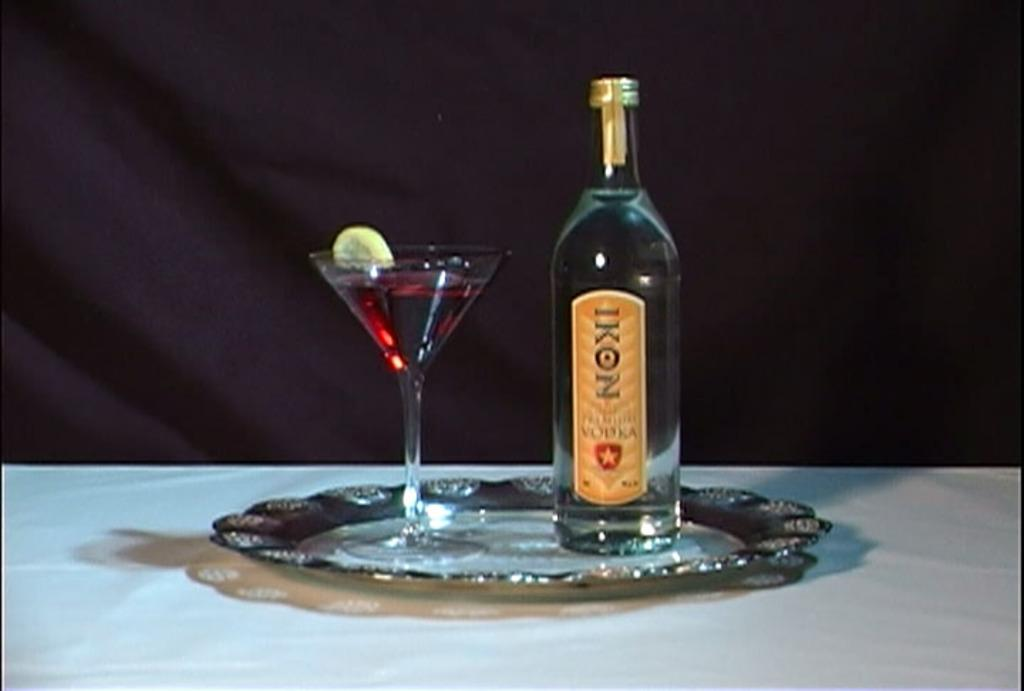What type of glass is visible in the image? There is a wine glass in the image. What type of alcoholic beverage is associated with the bottle in the image? There is a vodka bottle in the image. Where are the wine glass and the vodka bottle located in the image? Both the wine glass and the vodka bottle are placed on a table. What type of hat is visible on the table in the image? There is no hat present on the table in the image. What type of fruits or vegetables are visible on the table in the image? There is no produce visible on the table in the image. 